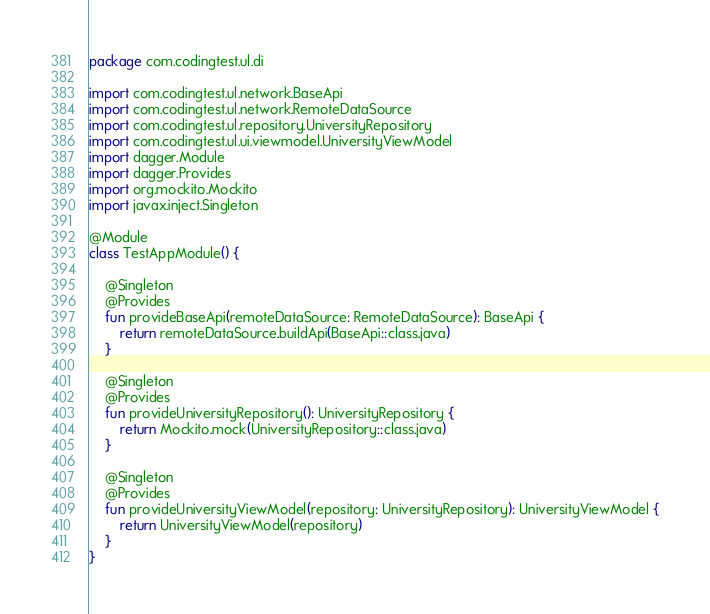<code> <loc_0><loc_0><loc_500><loc_500><_Kotlin_>package com.codingtest.ul.di

import com.codingtest.ul.network.BaseApi
import com.codingtest.ul.network.RemoteDataSource
import com.codingtest.ul.repository.UniversityRepository
import com.codingtest.ul.ui.viewmodel.UniversityViewModel
import dagger.Module
import dagger.Provides
import org.mockito.Mockito
import javax.inject.Singleton

@Module
class TestAppModule() {

    @Singleton
    @Provides
    fun provideBaseApi(remoteDataSource: RemoteDataSource): BaseApi {
        return remoteDataSource.buildApi(BaseApi::class.java)
    }

    @Singleton
    @Provides
    fun provideUniversityRepository(): UniversityRepository {
        return Mockito.mock(UniversityRepository::class.java)
    }

    @Singleton
    @Provides
    fun provideUniversityViewModel(repository: UniversityRepository): UniversityViewModel {
        return UniversityViewModel(repository)
    }
}</code> 